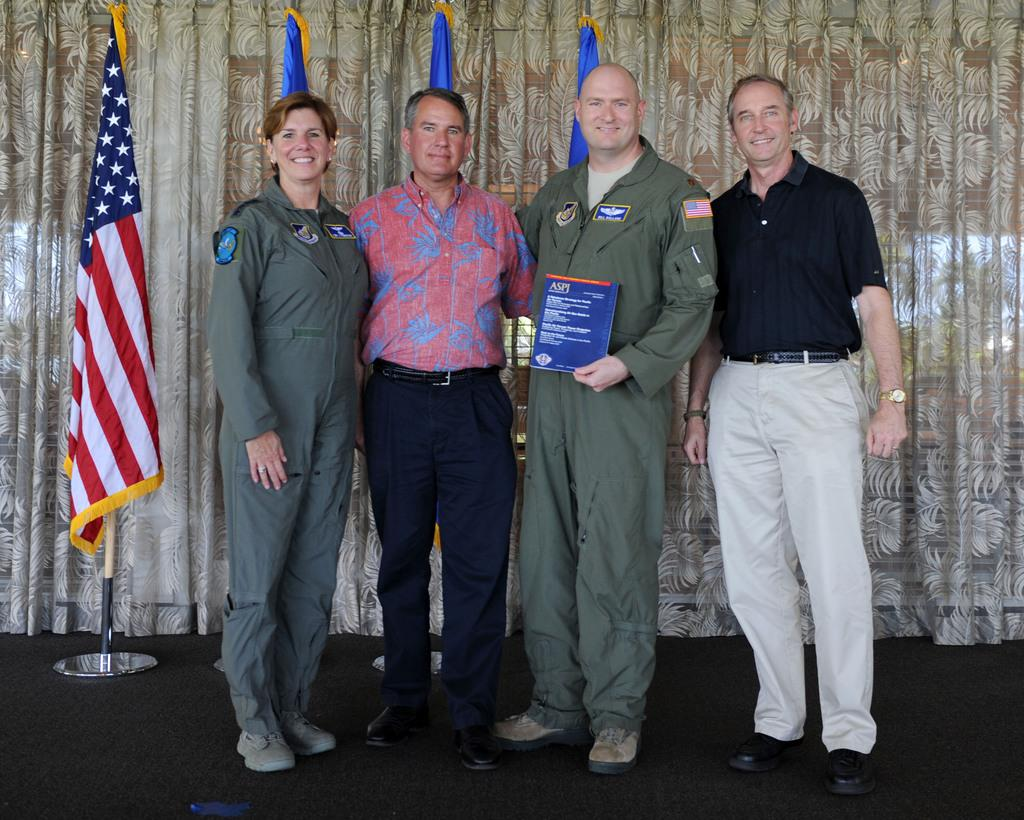What are the people in the image doing? The people in the image are standing and smiling. Can you describe the man in the center of the image? The man in the center of the image is standing and holding a board. What can be seen in the background of the image? There are flags and a curtain visible in the background of the image. How many ducks are sitting on the man's shoulders in the image? There are no ducks present in the image, so it is not possible to determine how many might be sitting on the man's shoulders. 